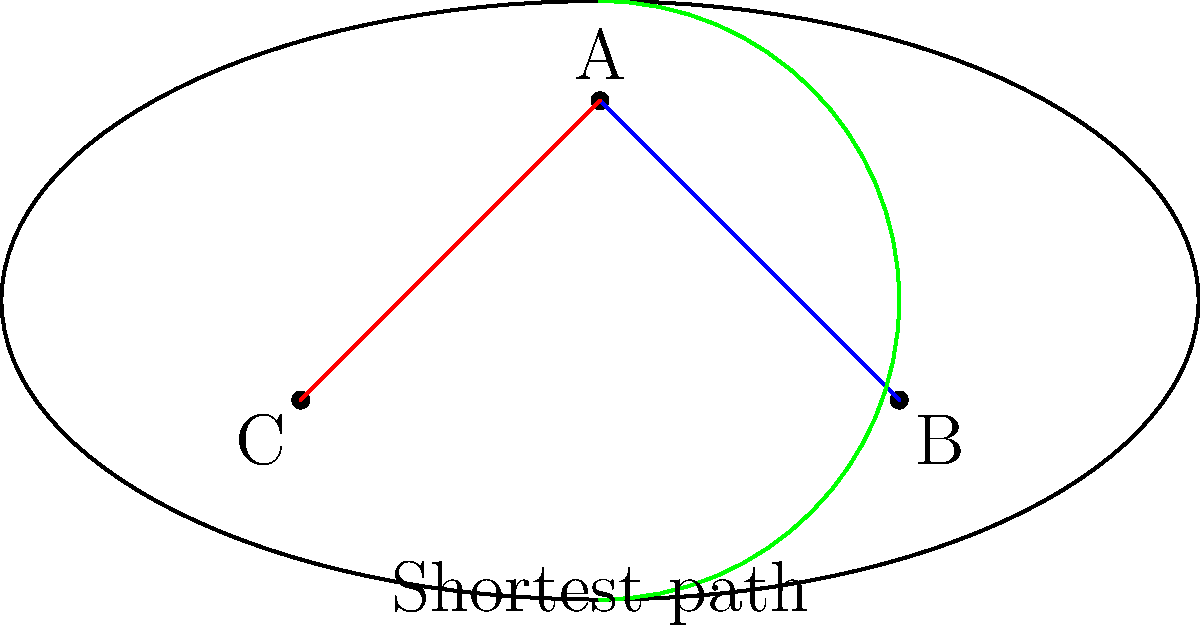In the Stade Mohammed V, home of Wydad AC, consider three points: A (center of the north stand), B (southeast corner), and C (southwest corner). Which path represents the shortest distance between A and B? To determine the shortest path between points A and B in the Stade Mohammed V, we need to consider the stadium's elliptical shape and the possible routes:

1. Direct path (blue line):
   This is a straight line connecting A and B. However, it passes through the stadium's interior, which is not a valid path for spectators.

2. Arc path (green curve):
   This path follows the stadium's perimeter from A to B. It's a valid path but longer than necessary.

3. Two-segment path (red line + part of blue line):
   This path goes from A to C, then from C to B along the stadium's perimeter. While valid, it's clearly longer than necessary as it overshoots point B.

The shortest valid path would be the one that follows the stadium's perimeter from A to B without overshooting. This path is not explicitly drawn in the diagram but would be a portion of the elliptical curve between A and B.

In a real stadium setting, this would represent walking along the concourse from the center of the north stand to the southeast corner, following the stadium's curvature.
Answer: The shortest path follows the stadium's perimeter directly from A to B. 